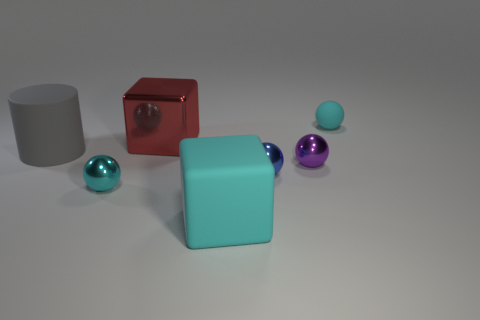What colors are featured in the objects within this image? The image features a variety of colors among the objects visible. Specifically, there is a red cube, a grey cylinder, a cyan cube, a sky blue sphere, and a small purple sphere. The colors are distinct and vivid, providing a visually stimulating contrast against the neutral background. 